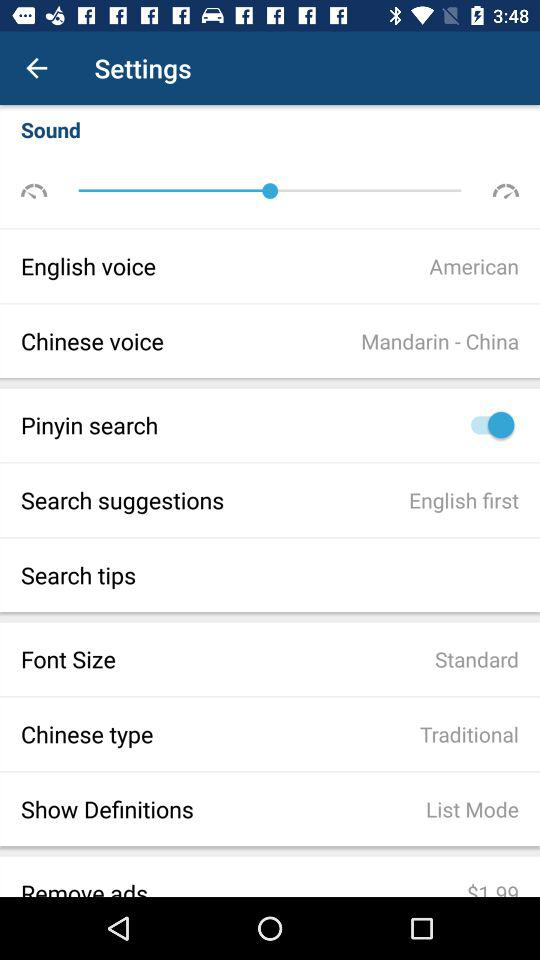What is the "Chinese type"? The "Chinese type" is traditional. 